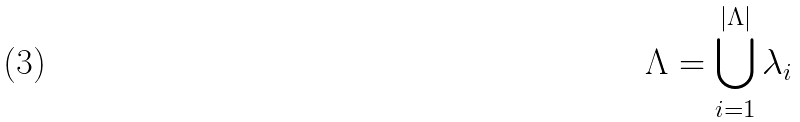<formula> <loc_0><loc_0><loc_500><loc_500>\text {$\Lambda = \bigcup_{i = 1}^{| \Lambda |} \lambda_{i}$}</formula> 